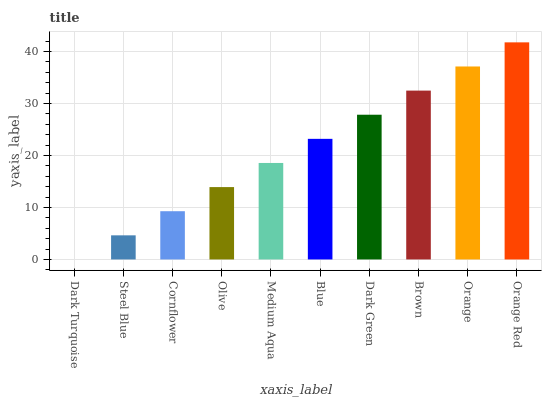Is Dark Turquoise the minimum?
Answer yes or no. Yes. Is Orange Red the maximum?
Answer yes or no. Yes. Is Steel Blue the minimum?
Answer yes or no. No. Is Steel Blue the maximum?
Answer yes or no. No. Is Steel Blue greater than Dark Turquoise?
Answer yes or no. Yes. Is Dark Turquoise less than Steel Blue?
Answer yes or no. Yes. Is Dark Turquoise greater than Steel Blue?
Answer yes or no. No. Is Steel Blue less than Dark Turquoise?
Answer yes or no. No. Is Blue the high median?
Answer yes or no. Yes. Is Medium Aqua the low median?
Answer yes or no. Yes. Is Olive the high median?
Answer yes or no. No. Is Steel Blue the low median?
Answer yes or no. No. 